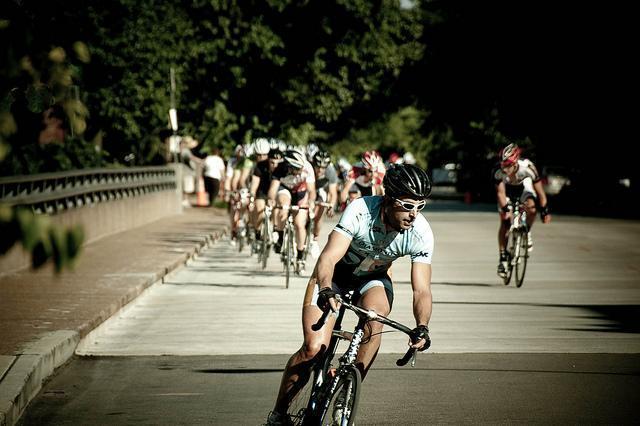What is the most likely reason the street is filled with bicyclists?
Make your selection and explain in format: 'Answer: answer
Rationale: rationale.'
Options: Training, race, parade, protest. Answer: race.
Rationale: There is a race that is happening. 